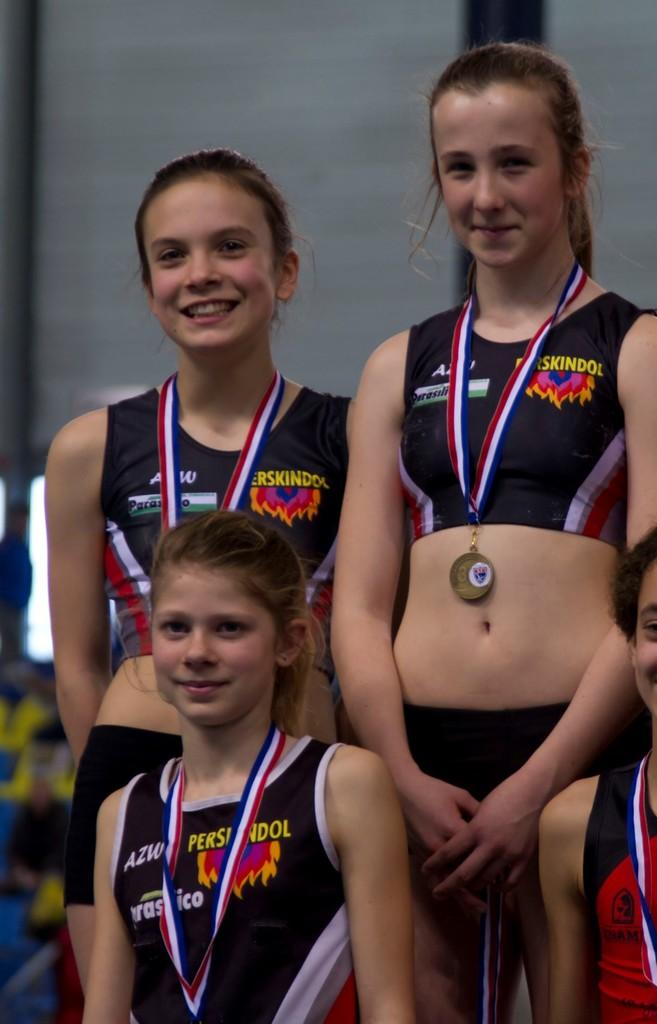<image>
Give a short and clear explanation of the subsequent image. Three girls wearing medals are wearing shirts with AZW on the upper right side of the shirt. 